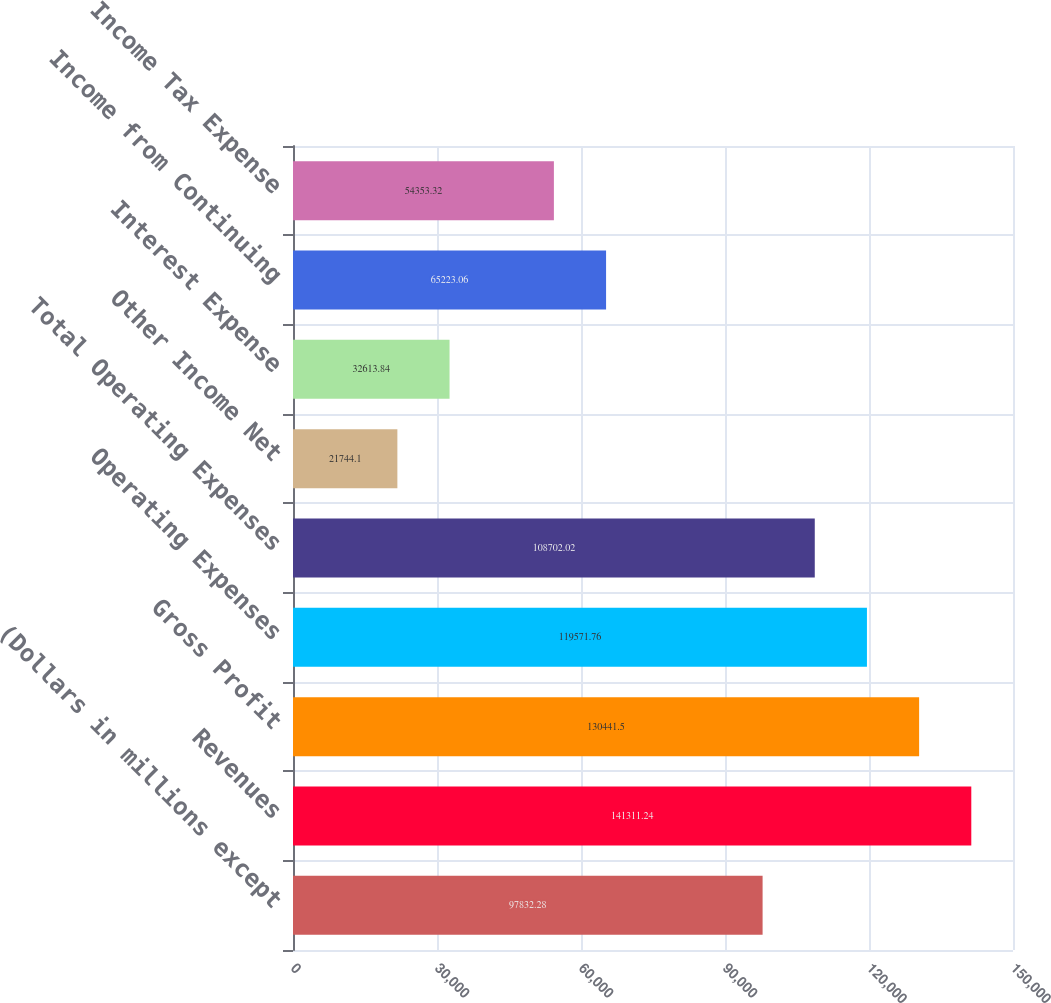<chart> <loc_0><loc_0><loc_500><loc_500><bar_chart><fcel>(Dollars in millions except<fcel>Revenues<fcel>Gross Profit<fcel>Operating Expenses<fcel>Total Operating Expenses<fcel>Other Income Net<fcel>Interest Expense<fcel>Income from Continuing<fcel>Income Tax Expense<nl><fcel>97832.3<fcel>141311<fcel>130442<fcel>119572<fcel>108702<fcel>21744.1<fcel>32613.8<fcel>65223.1<fcel>54353.3<nl></chart> 